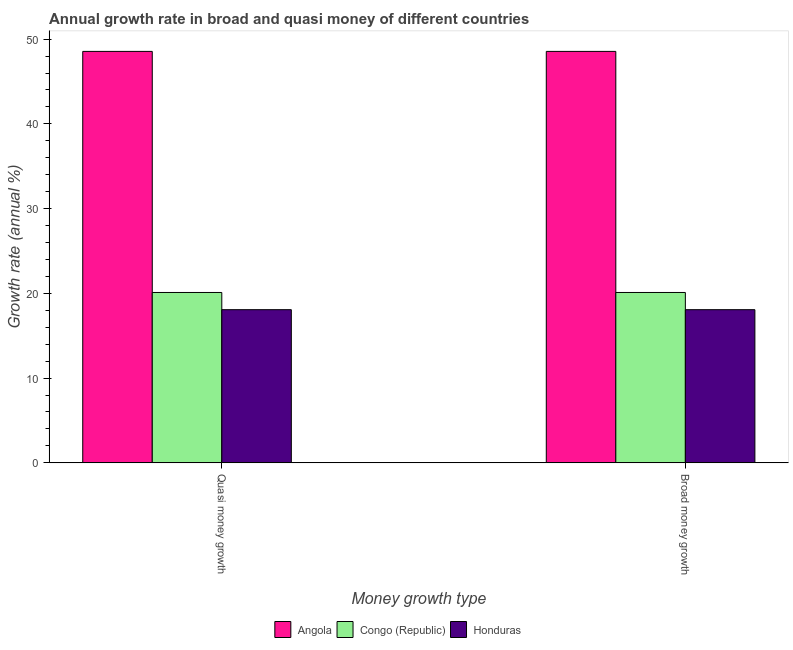Are the number of bars per tick equal to the number of legend labels?
Offer a very short reply. Yes. How many bars are there on the 1st tick from the left?
Your answer should be very brief. 3. How many bars are there on the 1st tick from the right?
Make the answer very short. 3. What is the label of the 2nd group of bars from the left?
Your response must be concise. Broad money growth. What is the annual growth rate in quasi money in Congo (Republic)?
Offer a terse response. 20.1. Across all countries, what is the maximum annual growth rate in broad money?
Offer a very short reply. 48.55. Across all countries, what is the minimum annual growth rate in quasi money?
Make the answer very short. 18.07. In which country was the annual growth rate in quasi money maximum?
Ensure brevity in your answer.  Angola. In which country was the annual growth rate in quasi money minimum?
Your answer should be very brief. Honduras. What is the total annual growth rate in quasi money in the graph?
Offer a terse response. 86.72. What is the difference between the annual growth rate in broad money in Congo (Republic) and that in Angola?
Ensure brevity in your answer.  -28.45. What is the difference between the annual growth rate in quasi money in Honduras and the annual growth rate in broad money in Angola?
Your answer should be very brief. -30.48. What is the average annual growth rate in broad money per country?
Provide a succinct answer. 28.91. In how many countries, is the annual growth rate in quasi money greater than 10 %?
Your answer should be very brief. 3. What is the ratio of the annual growth rate in quasi money in Angola to that in Honduras?
Your response must be concise. 2.69. In how many countries, is the annual growth rate in broad money greater than the average annual growth rate in broad money taken over all countries?
Give a very brief answer. 1. What does the 2nd bar from the left in Quasi money growth represents?
Ensure brevity in your answer.  Congo (Republic). What does the 2nd bar from the right in Quasi money growth represents?
Your response must be concise. Congo (Republic). Are all the bars in the graph horizontal?
Offer a terse response. No. How are the legend labels stacked?
Your answer should be very brief. Horizontal. What is the title of the graph?
Keep it short and to the point. Annual growth rate in broad and quasi money of different countries. Does "Sao Tome and Principe" appear as one of the legend labels in the graph?
Keep it short and to the point. No. What is the label or title of the X-axis?
Offer a terse response. Money growth type. What is the label or title of the Y-axis?
Ensure brevity in your answer.  Growth rate (annual %). What is the Growth rate (annual %) in Angola in Quasi money growth?
Your answer should be very brief. 48.55. What is the Growth rate (annual %) in Congo (Republic) in Quasi money growth?
Offer a very short reply. 20.1. What is the Growth rate (annual %) of Honduras in Quasi money growth?
Give a very brief answer. 18.07. What is the Growth rate (annual %) of Angola in Broad money growth?
Your response must be concise. 48.55. What is the Growth rate (annual %) of Congo (Republic) in Broad money growth?
Your answer should be compact. 20.1. What is the Growth rate (annual %) of Honduras in Broad money growth?
Your answer should be very brief. 18.07. Across all Money growth type, what is the maximum Growth rate (annual %) in Angola?
Make the answer very short. 48.55. Across all Money growth type, what is the maximum Growth rate (annual %) of Congo (Republic)?
Offer a very short reply. 20.1. Across all Money growth type, what is the maximum Growth rate (annual %) of Honduras?
Offer a very short reply. 18.07. Across all Money growth type, what is the minimum Growth rate (annual %) of Angola?
Provide a succinct answer. 48.55. Across all Money growth type, what is the minimum Growth rate (annual %) of Congo (Republic)?
Provide a short and direct response. 20.1. Across all Money growth type, what is the minimum Growth rate (annual %) in Honduras?
Your response must be concise. 18.07. What is the total Growth rate (annual %) in Angola in the graph?
Provide a short and direct response. 97.1. What is the total Growth rate (annual %) of Congo (Republic) in the graph?
Offer a terse response. 40.2. What is the total Growth rate (annual %) of Honduras in the graph?
Provide a short and direct response. 36.14. What is the difference between the Growth rate (annual %) of Angola in Quasi money growth and that in Broad money growth?
Offer a very short reply. 0. What is the difference between the Growth rate (annual %) in Angola in Quasi money growth and the Growth rate (annual %) in Congo (Republic) in Broad money growth?
Provide a short and direct response. 28.45. What is the difference between the Growth rate (annual %) in Angola in Quasi money growth and the Growth rate (annual %) in Honduras in Broad money growth?
Your answer should be compact. 30.48. What is the difference between the Growth rate (annual %) in Congo (Republic) in Quasi money growth and the Growth rate (annual %) in Honduras in Broad money growth?
Provide a short and direct response. 2.03. What is the average Growth rate (annual %) of Angola per Money growth type?
Give a very brief answer. 48.55. What is the average Growth rate (annual %) in Congo (Republic) per Money growth type?
Keep it short and to the point. 20.1. What is the average Growth rate (annual %) in Honduras per Money growth type?
Keep it short and to the point. 18.07. What is the difference between the Growth rate (annual %) in Angola and Growth rate (annual %) in Congo (Republic) in Quasi money growth?
Provide a short and direct response. 28.45. What is the difference between the Growth rate (annual %) of Angola and Growth rate (annual %) of Honduras in Quasi money growth?
Provide a succinct answer. 30.48. What is the difference between the Growth rate (annual %) of Congo (Republic) and Growth rate (annual %) of Honduras in Quasi money growth?
Provide a succinct answer. 2.03. What is the difference between the Growth rate (annual %) of Angola and Growth rate (annual %) of Congo (Republic) in Broad money growth?
Your answer should be very brief. 28.45. What is the difference between the Growth rate (annual %) in Angola and Growth rate (annual %) in Honduras in Broad money growth?
Make the answer very short. 30.48. What is the difference between the Growth rate (annual %) of Congo (Republic) and Growth rate (annual %) of Honduras in Broad money growth?
Make the answer very short. 2.03. What is the ratio of the Growth rate (annual %) in Congo (Republic) in Quasi money growth to that in Broad money growth?
Offer a very short reply. 1. What is the difference between the highest and the second highest Growth rate (annual %) of Angola?
Your answer should be compact. 0. What is the difference between the highest and the lowest Growth rate (annual %) in Honduras?
Offer a terse response. 0. 